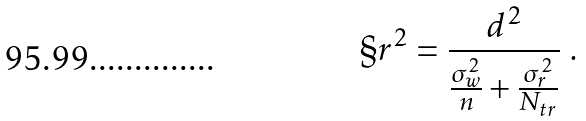<formula> <loc_0><loc_0><loc_500><loc_500>\S r ^ { 2 } = \frac { d ^ { 2 } } { \frac { \sigma _ { w } ^ { 2 } } { n } + \frac { \sigma ^ { 2 } _ { r } } { N _ { t r } } } \ .</formula> 